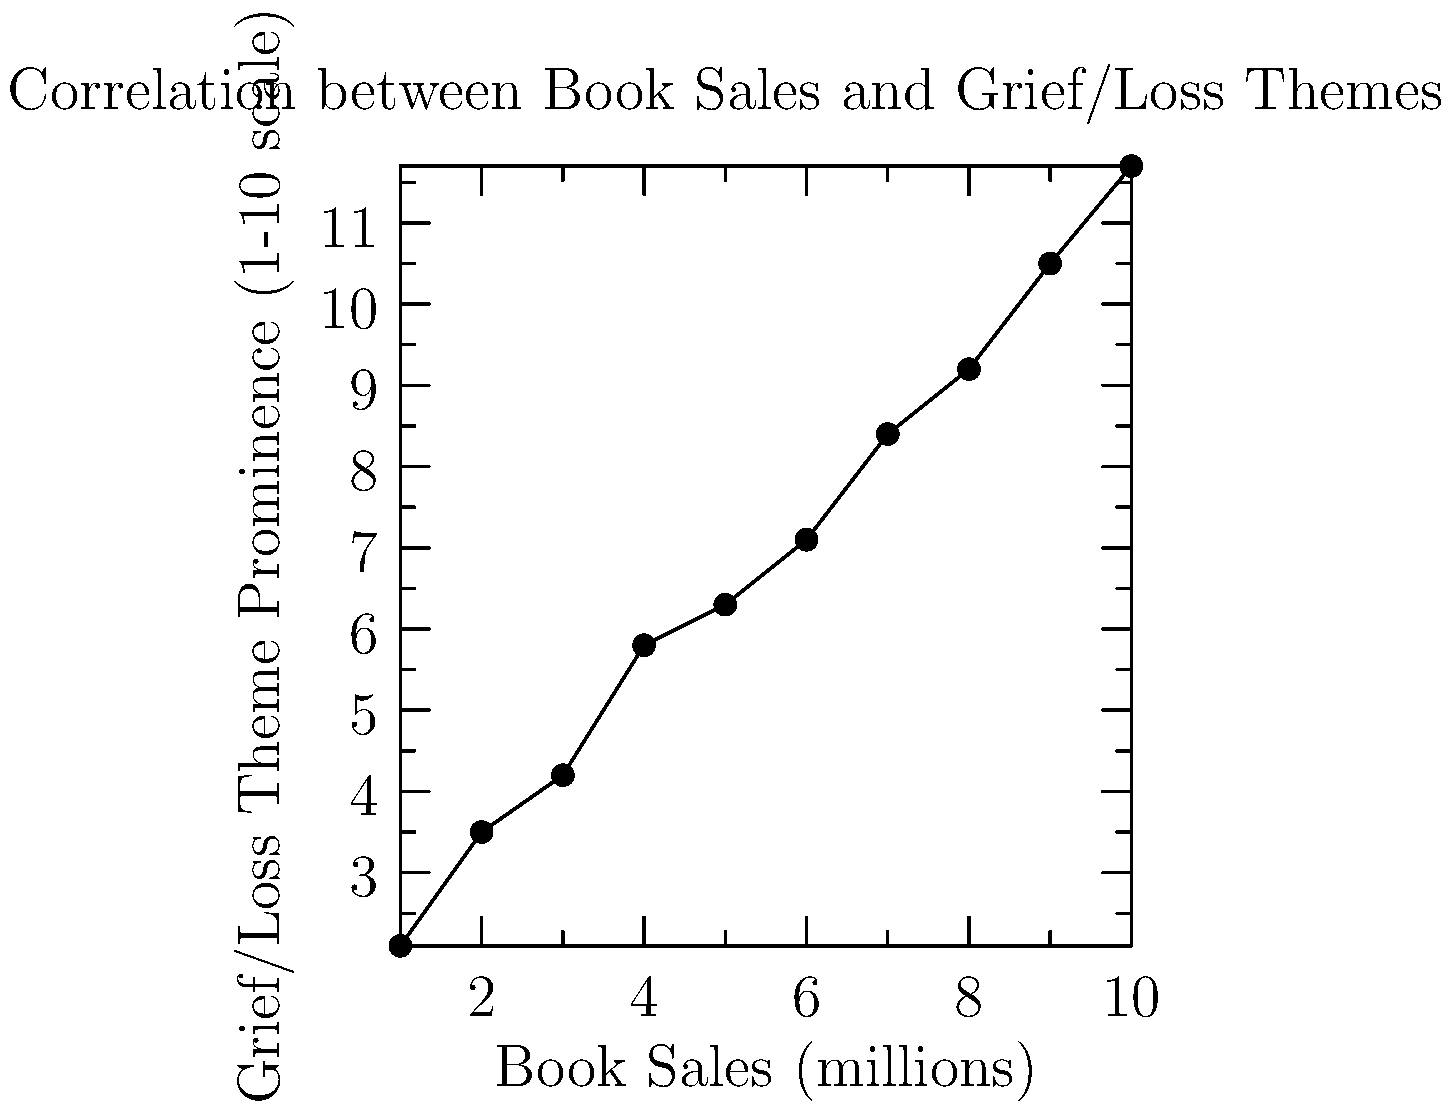Based on the scatter plot, which of the following statements best describes the relationship between book sales and the prominence of grief/loss themes in contemporary fiction?

A) There is a strong negative correlation
B) There is no clear correlation
C) There is a strong positive correlation
D) There is a weak negative correlation To determine the relationship between book sales and the prominence of grief/loss themes, we need to analyze the scatter plot:

1. Observe the overall trend: As we move from left to right (increasing book sales), the data points generally move upward (increasing theme prominence).

2. Assess the strength of the relationship: The points form a relatively tight, linear pattern with minimal scatter.

3. Determine the direction: The upward trend indicates a positive relationship.

4. Evaluate the consistency: There are no significant outliers or deviations from the general trend.

5. Compare with the given options:
   A) Strong negative correlation: Incorrect, as the trend is positive.
   B) No clear correlation: Incorrect, as there is a clear pattern.
   C) Strong positive correlation: Correct, as the data shows a clear, consistent upward trend.
   D) Weak negative correlation: Incorrect, as the correlation is neither weak nor negative.

Given these observations, the data suggests a strong positive correlation between book sales and the prominence of grief/loss themes in contemporary fiction.
Answer: C) There is a strong positive correlation 